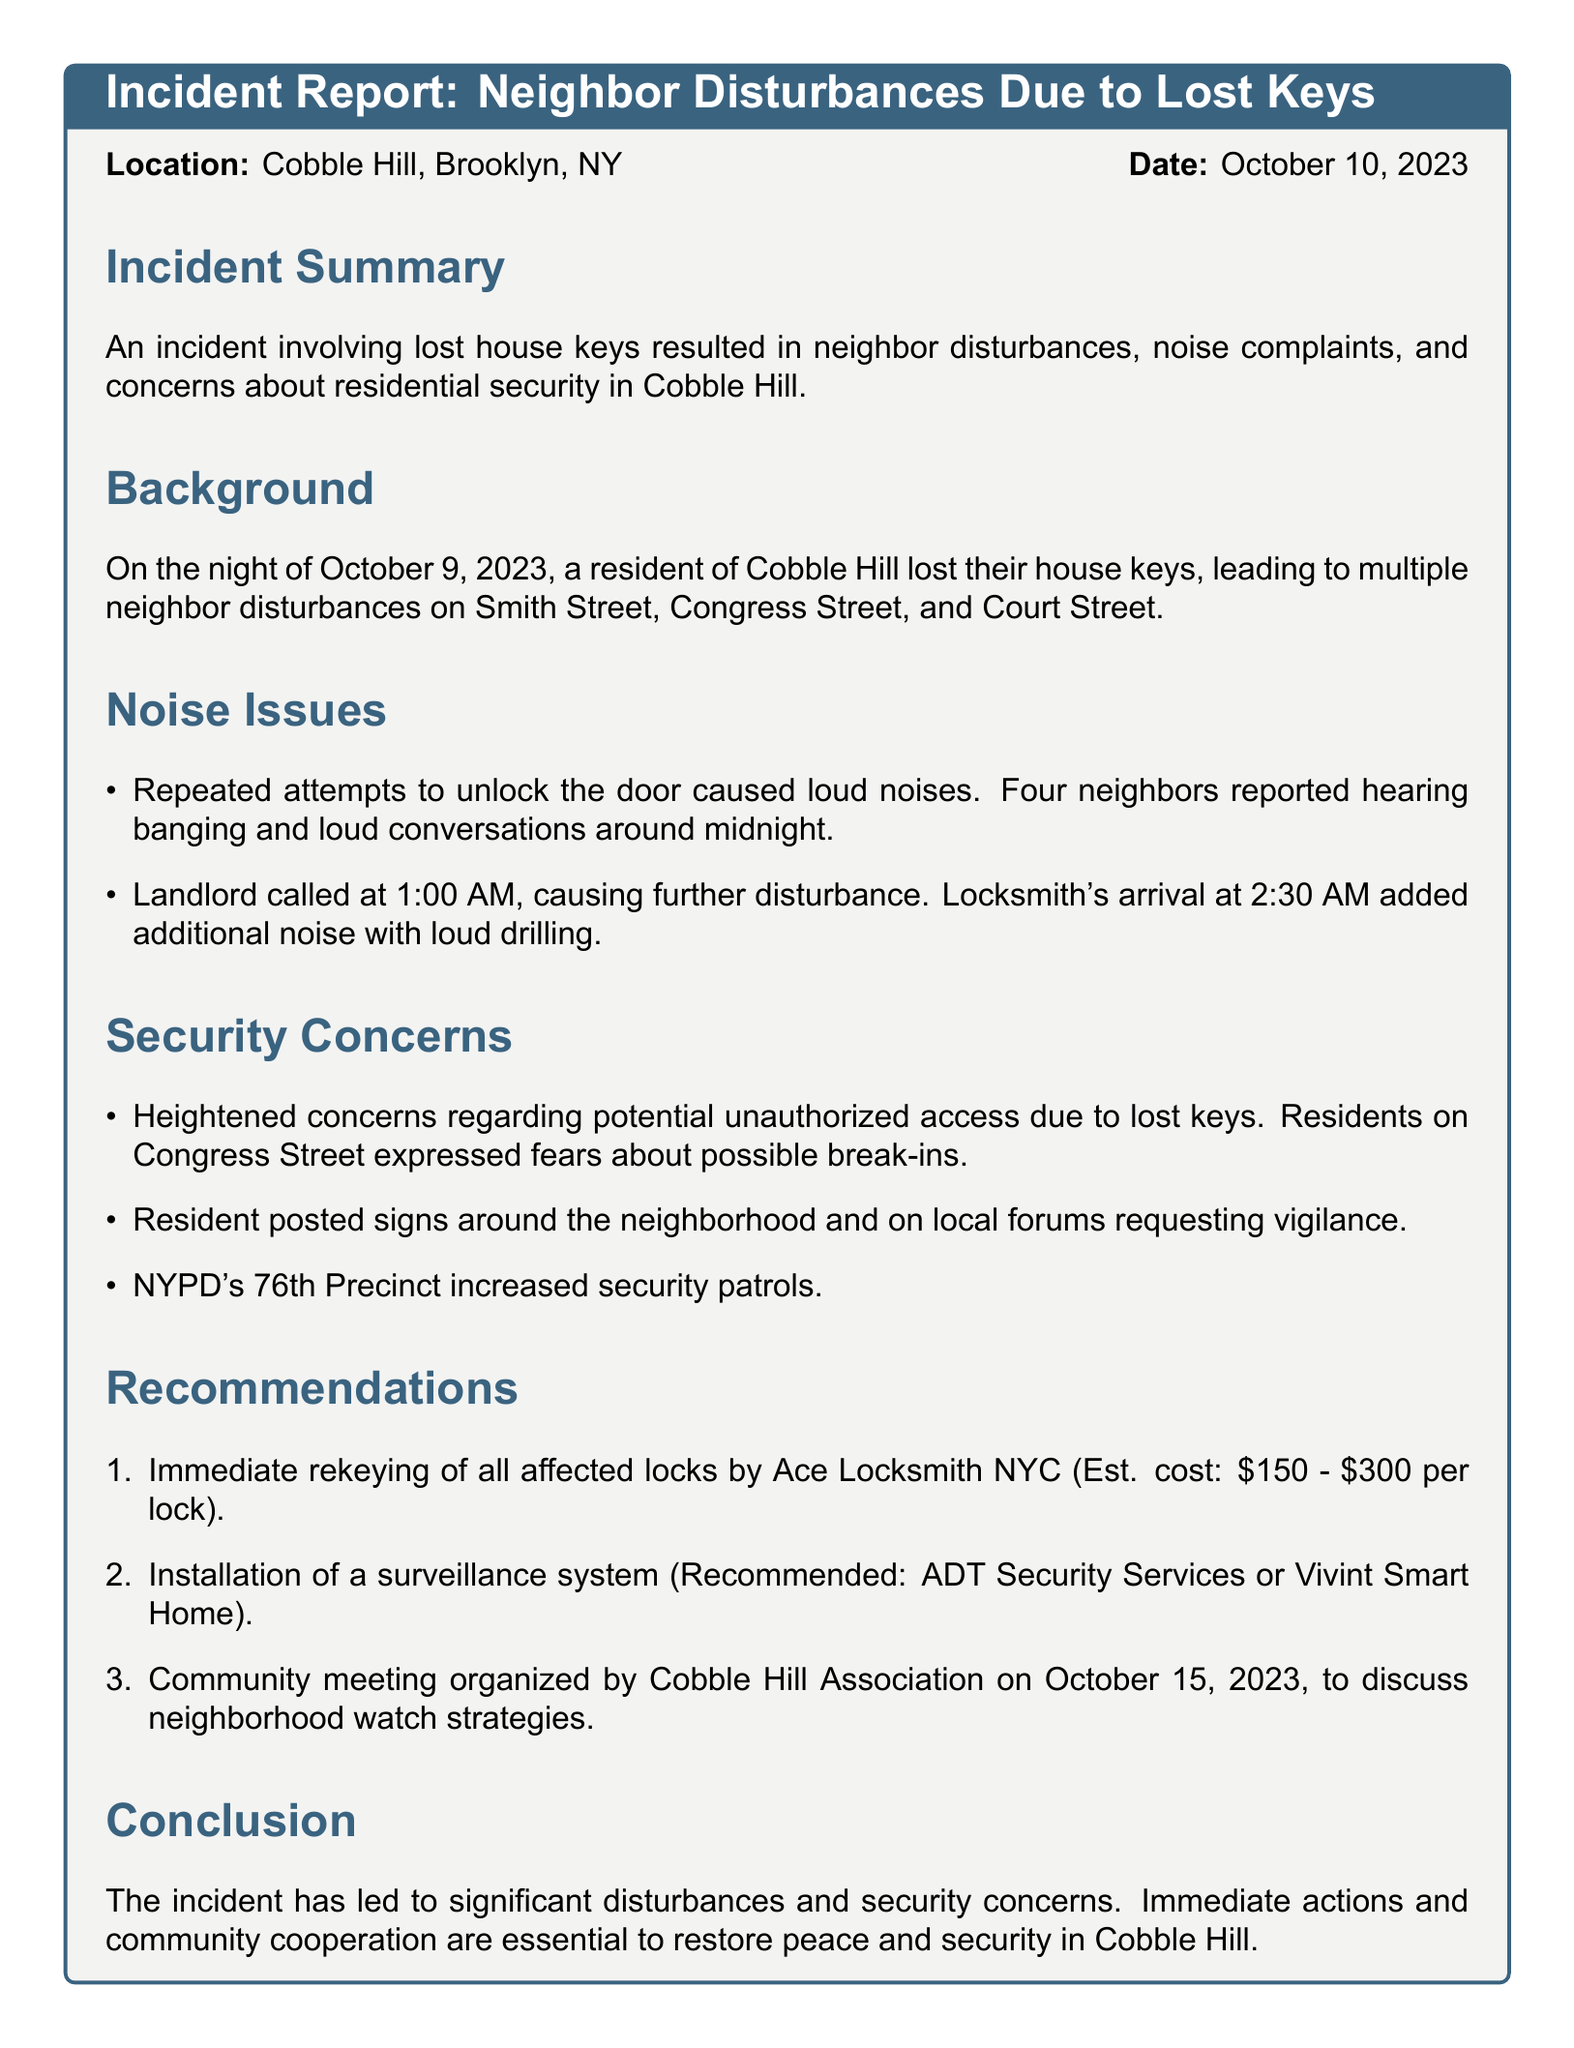What was the incident date? The incident date is called out in the document as October 10, 2023.
Answer: October 10, 2023 What did the resident lose? The document mentions that a resident lost their house keys.
Answer: House keys At what time did the landlord call? The specific time of the landlord's call is addressed in the noise issues section as 1:00 AM.
Answer: 1:00 AM How many locks are recommended to be rekeyed? The recommendation does not specify a number, but it implies all affected locks should be rekeyed.
Answer: All affected locks Which locksmith service is recommended? The incident report mentions Ace Locksmith NYC as the recommended service for rekeying.
Answer: Ace Locksmith NYC What time did the locksmith arrive? The locksmith's arrival time is noted in the noise issues section as 2:30 AM.
Answer: 2:30 AM What increase in security was requested by the local police? The document states that the NYPD's 76th Precinct increased security patrols in the neighborhood.
Answer: Increased security patrols When is the community meeting scheduled? The document indicates the community meeting is organized for October 15, 2023.
Answer: October 15, 2023 What financial estimate is mentioned for the rekeying service? The estimated cost for rekeying locks is presented in the recommendations as \$150 - \$300 per lock.
Answer: \$150 - \$300 per lock 